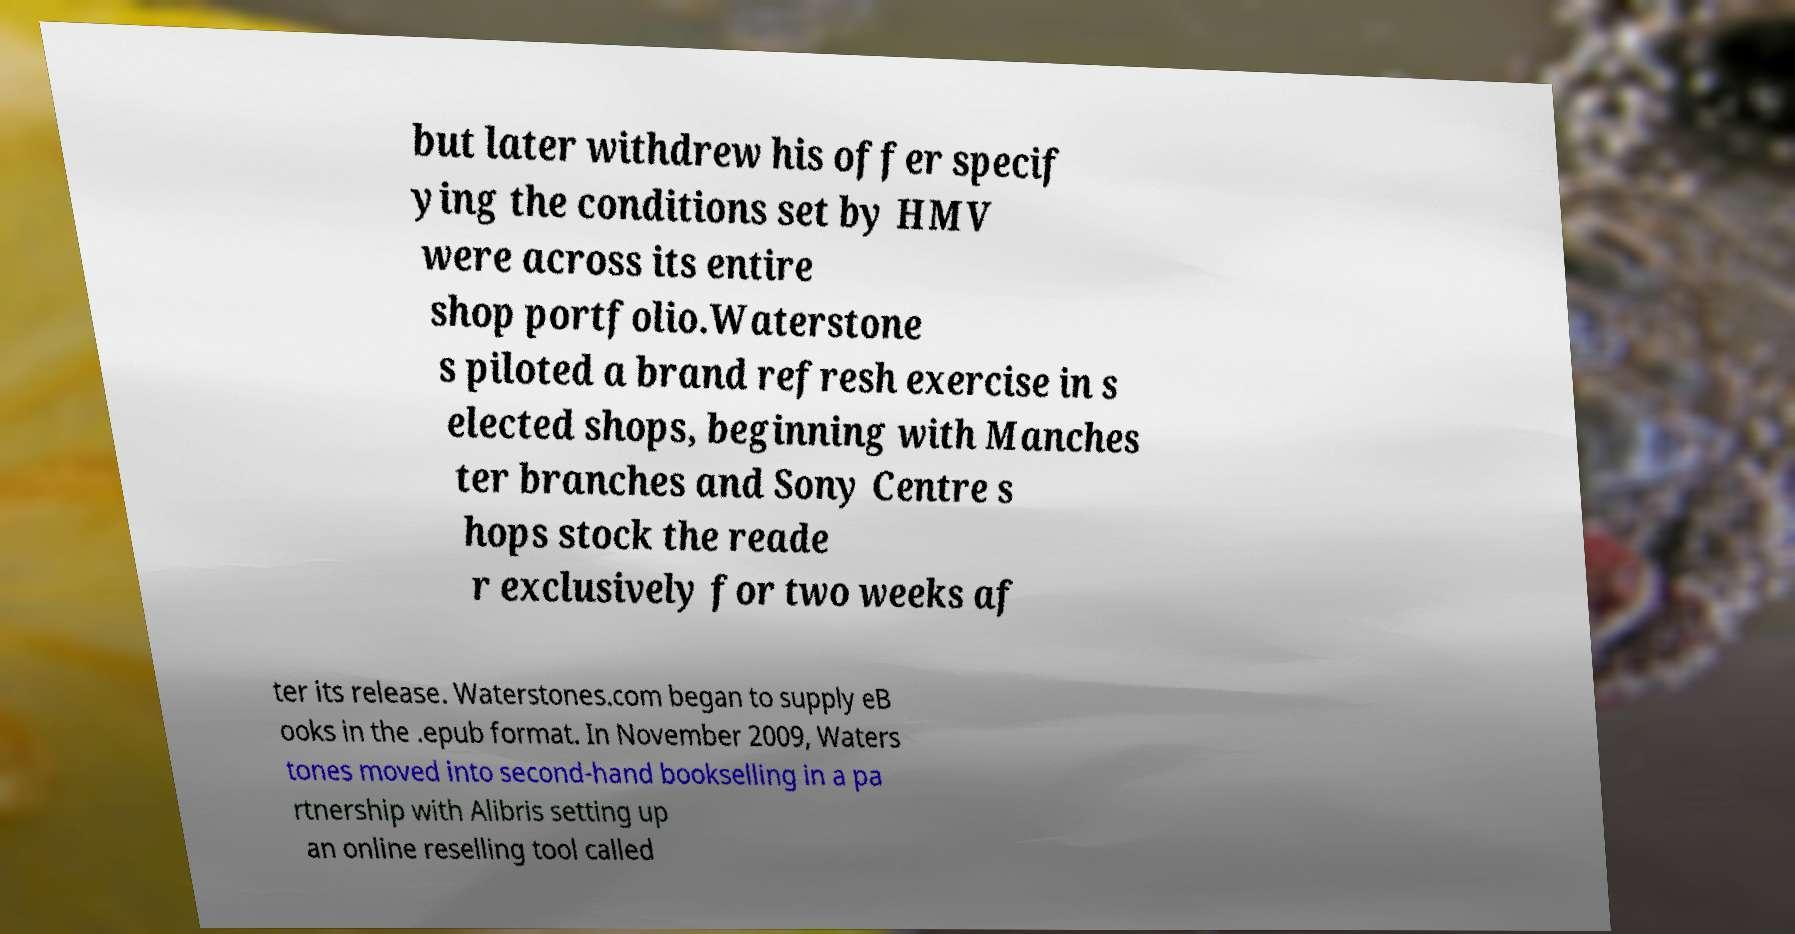Could you extract and type out the text from this image? but later withdrew his offer specif ying the conditions set by HMV were across its entire shop portfolio.Waterstone s piloted a brand refresh exercise in s elected shops, beginning with Manches ter branches and Sony Centre s hops stock the reade r exclusively for two weeks af ter its release. Waterstones.com began to supply eB ooks in the .epub format. In November 2009, Waters tones moved into second-hand bookselling in a pa rtnership with Alibris setting up an online reselling tool called 